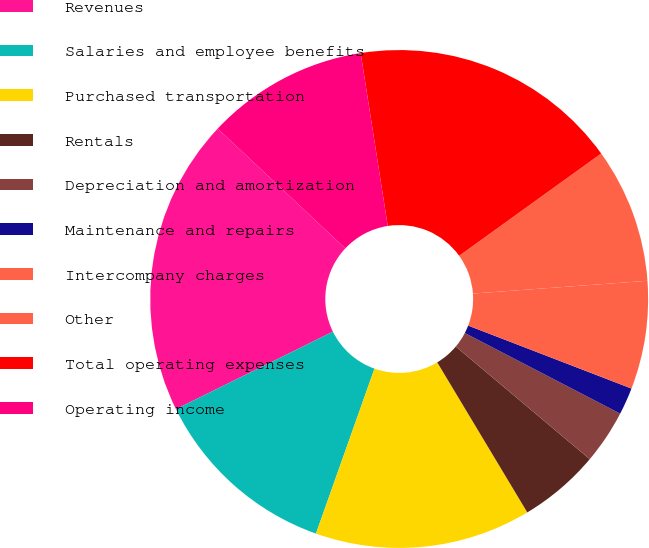Convert chart to OTSL. <chart><loc_0><loc_0><loc_500><loc_500><pie_chart><fcel>Revenues<fcel>Salaries and employee benefits<fcel>Purchased transportation<fcel>Rentals<fcel>Depreciation and amortization<fcel>Maintenance and repairs<fcel>Intercompany charges<fcel>Other<fcel>Total operating expenses<fcel>Operating income<nl><fcel>19.29%<fcel>12.28%<fcel>14.03%<fcel>5.27%<fcel>3.51%<fcel>1.76%<fcel>7.02%<fcel>8.77%<fcel>17.54%<fcel>10.53%<nl></chart> 